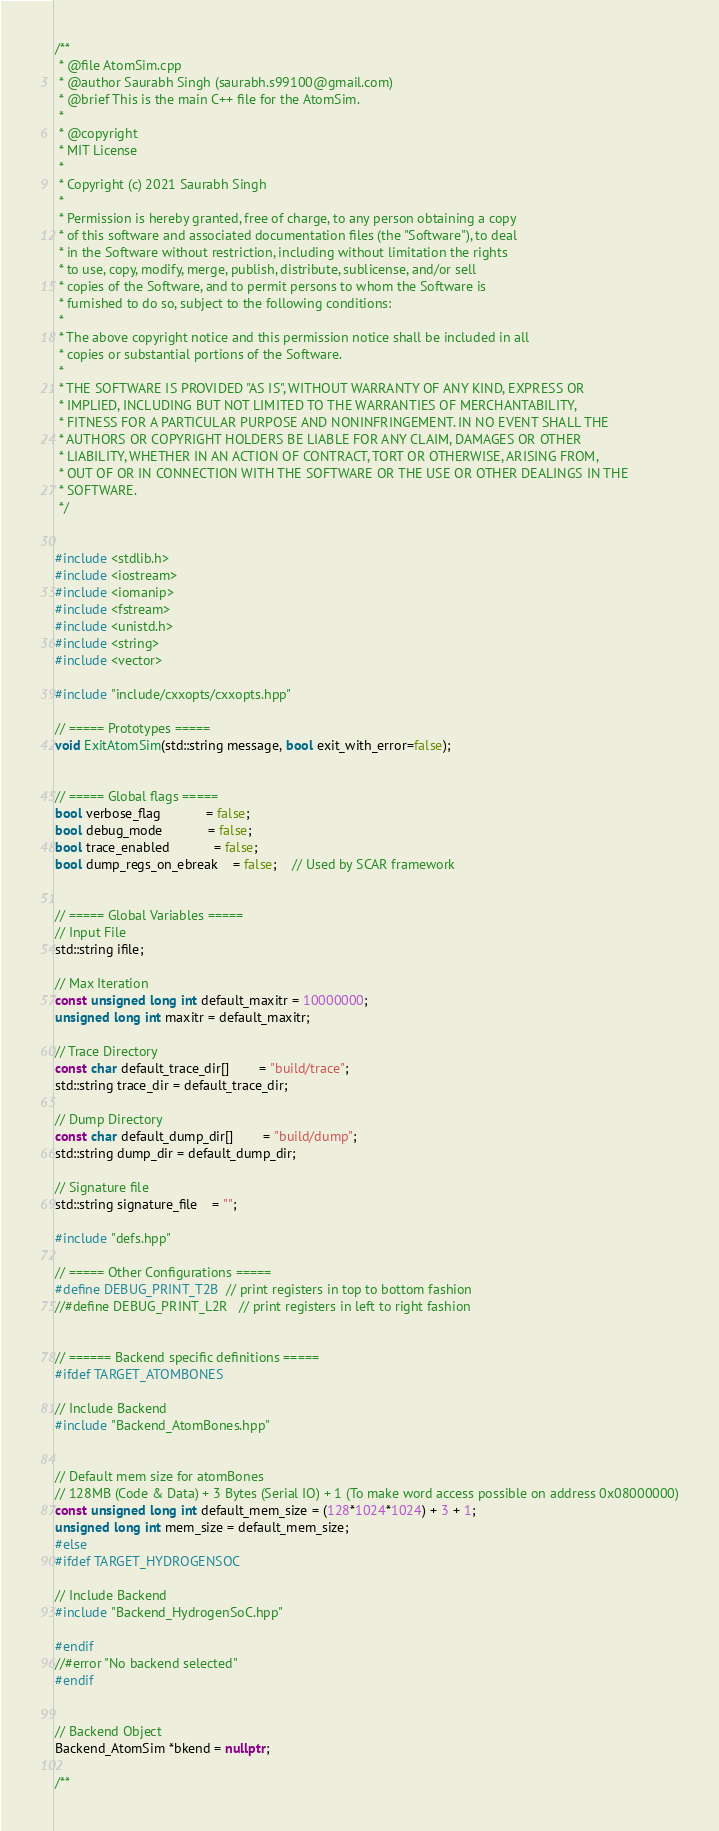<code> <loc_0><loc_0><loc_500><loc_500><_C++_>/**
 * @file AtomSim.cpp
 * @author Saurabh Singh (saurabh.s99100@gmail.com)
 * @brief This is the main C++ file for the AtomSim.
 * 
 * @copyright 
 * MIT License
 *
 * Copyright (c) 2021 Saurabh Singh
 *
 * Permission is hereby granted, free of charge, to any person obtaining a copy
 * of this software and associated documentation files (the "Software"), to deal
 * in the Software without restriction, including without limitation the rights
 * to use, copy, modify, merge, publish, distribute, sublicense, and/or sell
 * copies of the Software, and to permit persons to whom the Software is
 * furnished to do so, subject to the following conditions:
 *
 * The above copyright notice and this permission notice shall be included in all
 * copies or substantial portions of the Software.
 *
 * THE SOFTWARE IS PROVIDED "AS IS", WITHOUT WARRANTY OF ANY KIND, EXPRESS OR
 * IMPLIED, INCLUDING BUT NOT LIMITED TO THE WARRANTIES OF MERCHANTABILITY,
 * FITNESS FOR A PARTICULAR PURPOSE AND NONINFRINGEMENT. IN NO EVENT SHALL THE
 * AUTHORS OR COPYRIGHT HOLDERS BE LIABLE FOR ANY CLAIM, DAMAGES OR OTHER
 * LIABILITY, WHETHER IN AN ACTION OF CONTRACT, TORT OR OTHERWISE, ARISING FROM,
 * OUT OF OR IN CONNECTION WITH THE SOFTWARE OR THE USE OR OTHER DEALINGS IN THE
 * SOFTWARE.
 */


#include <stdlib.h>
#include <iostream>
#include <iomanip>
#include <fstream>
#include <unistd.h>
#include <string>
#include <vector>

#include "include/cxxopts/cxxopts.hpp"

// ===== Prototypes =====
void ExitAtomSim(std::string message, bool exit_with_error=false);


// ===== Global flags =====
bool verbose_flag 			= false;
bool debug_mode 			= false;
bool trace_enabled 			= false;
bool dump_regs_on_ebreak 	= false;	// Used by SCAR framework


// ===== Global Variables =====
// Input File
std::string ifile;

// Max Iteration
const unsigned long int default_maxitr = 10000000;
unsigned long int maxitr = default_maxitr;

// Trace Directory
const char default_trace_dir[] 		= "build/trace";
std::string trace_dir = default_trace_dir;

// Dump Directory
const char default_dump_dir[] 		= "build/dump";
std::string dump_dir = default_dump_dir;

// Signature file
std::string signature_file 	= "";

#include "defs.hpp"

// ===== Other Configurations =====
#define DEBUG_PRINT_T2B	// print registers in top to bottom fashion 
//#define DEBUG_PRINT_L2R	// print registers in left to right fashion 


// ====== Backend specific definitions =====
#ifdef TARGET_ATOMBONES

// Include Backend
#include "Backend_AtomBones.hpp"


// Default mem size for atomBones
// 128MB (Code & Data) + 3 Bytes (Serial IO) + 1 (To make word access possible on address 0x08000000)
const unsigned long int default_mem_size = (128*1024*1024) + 3 + 1;	
unsigned long int mem_size = default_mem_size;
#else
#ifdef TARGET_HYDROGENSOC

// Include Backend
#include "Backend_HydrogenSoC.hpp"

#endif
//#error "No backend selected"
#endif


// Backend Object
Backend_AtomSim *bkend = nullptr;

/**</code> 